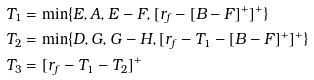<formula> <loc_0><loc_0><loc_500><loc_500>T _ { 1 } & = \min \{ E , A , E - F , [ r _ { f } - [ B - F ] ^ { + } ] ^ { + } \} \\ T _ { 2 } & = \min \{ D , G , G - H , [ r _ { f } - T _ { 1 } - [ B - F ] ^ { + } ] ^ { + } \} \\ T _ { 3 } & = [ r _ { f } - T _ { 1 } - T _ { 2 } ] ^ { + }</formula> 